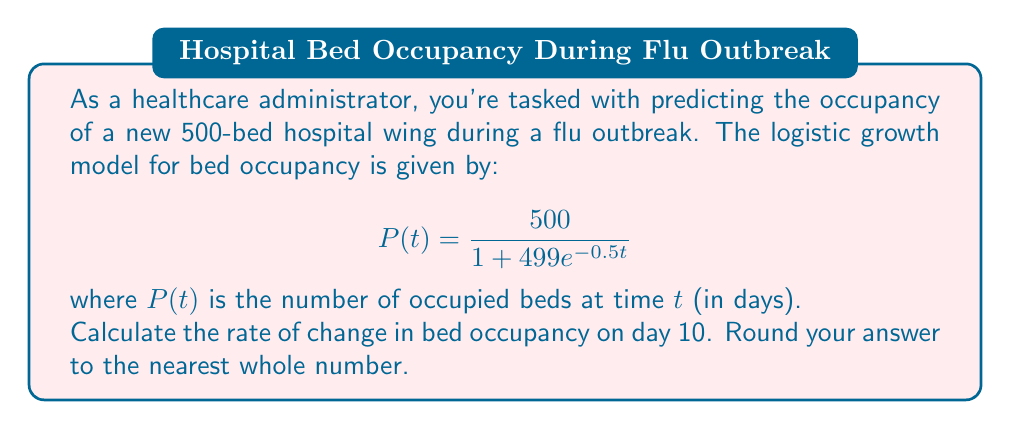Solve this math problem. To solve this problem, we need to find the derivative of the logistic growth function and evaluate it at t = 10. Here's the step-by-step process:

1) The given logistic growth function is:
   $$P(t) = \frac{500}{1 + 499e^{-0.5t}}$$

2) To find the rate of change, we need to differentiate P(t) with respect to t:
   $$P'(t) = \frac{d}{dt}\left(\frac{500}{1 + 499e^{-0.5t}}\right)$$

3) Using the quotient rule, we get:
   $$P'(t) = \frac{500 \cdot (499e^{-0.5t} \cdot 0.5)}{(1 + 499e^{-0.5t})^2}$$

4) Simplifying:
   $$P'(t) = \frac{124750e^{-0.5t}}{(1 + 499e^{-0.5t})^2}$$

5) Now, we need to evaluate this at t = 10:
   $$P'(10) = \frac{124750e^{-5}}{(1 + 499e^{-5})^2}$$

6) Using a calculator:
   $$P'(10) \approx 61.59$$

7) Rounding to the nearest whole number:
   $$P'(10) \approx 62$$

Therefore, on day 10, the rate of change in bed occupancy is approximately 62 beds per day.
Answer: 62 beds per day 